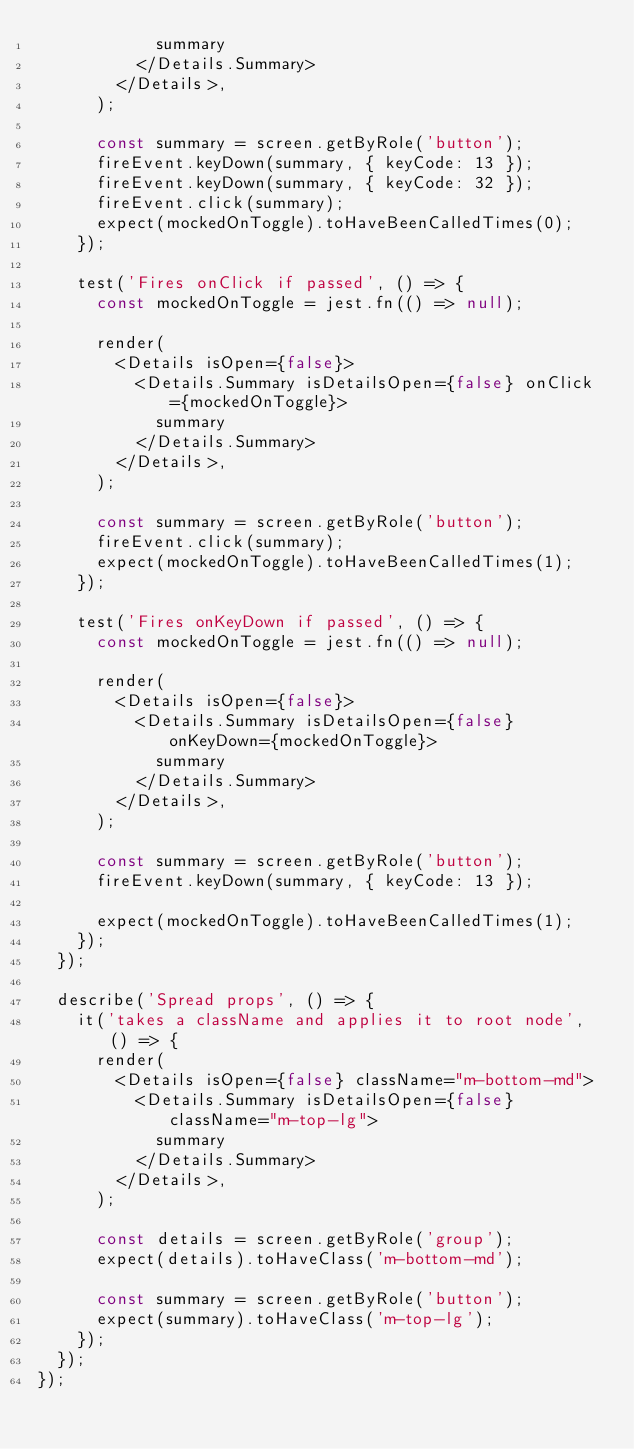Convert code to text. <code><loc_0><loc_0><loc_500><loc_500><_TypeScript_>            summary
          </Details.Summary>
        </Details>,
      );

      const summary = screen.getByRole('button');
      fireEvent.keyDown(summary, { keyCode: 13 });
      fireEvent.keyDown(summary, { keyCode: 32 });
      fireEvent.click(summary);
      expect(mockedOnToggle).toHaveBeenCalledTimes(0);
    });

    test('Fires onClick if passed', () => {
      const mockedOnToggle = jest.fn(() => null);

      render(
        <Details isOpen={false}>
          <Details.Summary isDetailsOpen={false} onClick={mockedOnToggle}>
            summary
          </Details.Summary>
        </Details>,
      );

      const summary = screen.getByRole('button');
      fireEvent.click(summary);
      expect(mockedOnToggle).toHaveBeenCalledTimes(1);
    });

    test('Fires onKeyDown if passed', () => {
      const mockedOnToggle = jest.fn(() => null);

      render(
        <Details isOpen={false}>
          <Details.Summary isDetailsOpen={false} onKeyDown={mockedOnToggle}>
            summary
          </Details.Summary>
        </Details>,
      );

      const summary = screen.getByRole('button');
      fireEvent.keyDown(summary, { keyCode: 13 });

      expect(mockedOnToggle).toHaveBeenCalledTimes(1);
    });
  });

  describe('Spread props', () => {
    it('takes a className and applies it to root node', () => {
      render(
        <Details isOpen={false} className="m-bottom-md">
          <Details.Summary isDetailsOpen={false} className="m-top-lg">
            summary
          </Details.Summary>
        </Details>,
      );

      const details = screen.getByRole('group');
      expect(details).toHaveClass('m-bottom-md');

      const summary = screen.getByRole('button');
      expect(summary).toHaveClass('m-top-lg');
    });
  });
});
</code> 